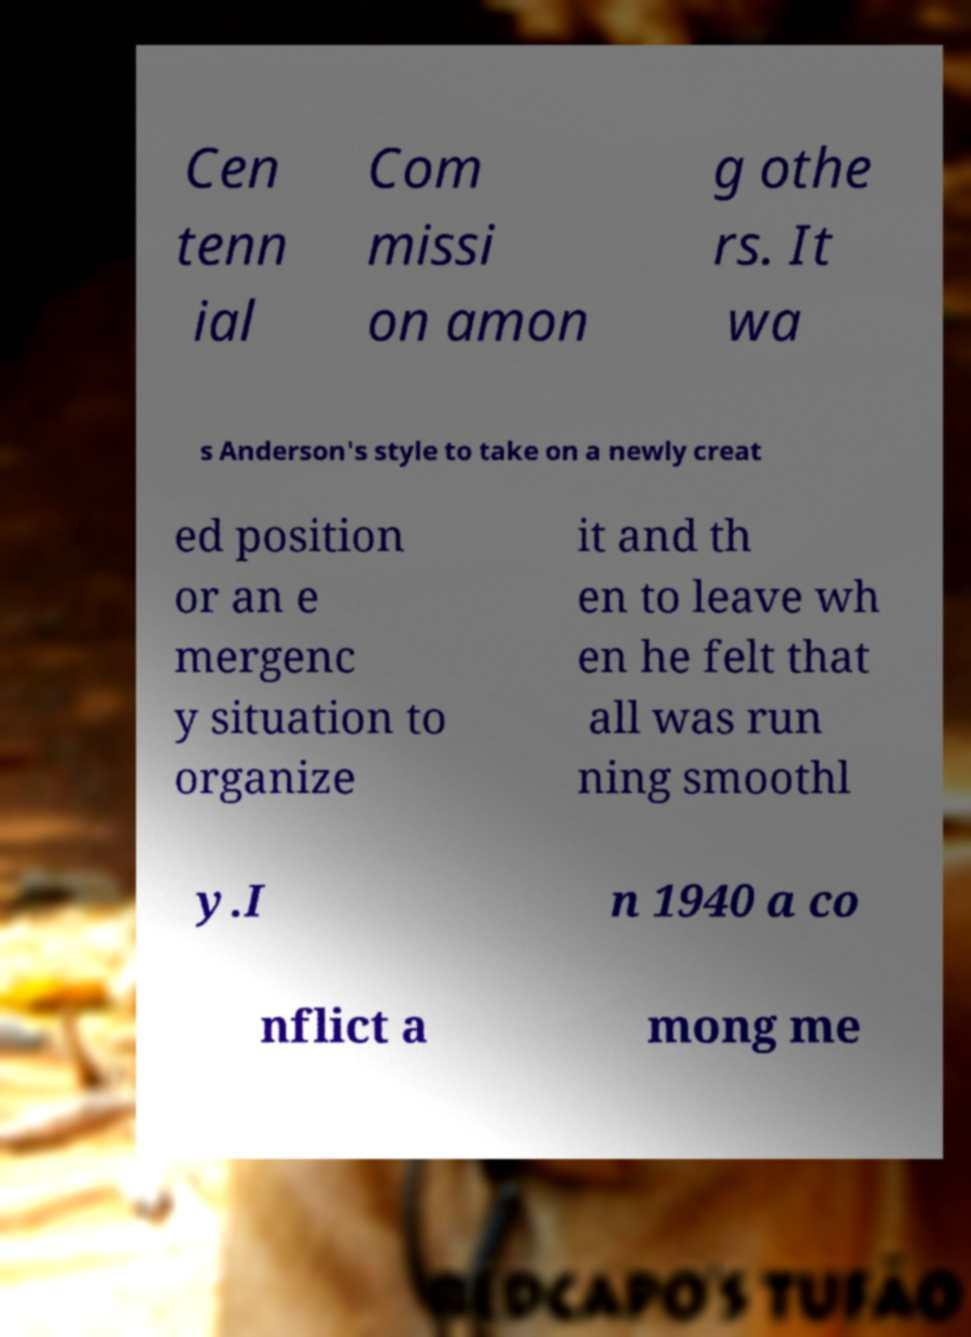Could you extract and type out the text from this image? Cen tenn ial Com missi on amon g othe rs. It wa s Anderson's style to take on a newly creat ed position or an e mergenc y situation to organize it and th en to leave wh en he felt that all was run ning smoothl y.I n 1940 a co nflict a mong me 